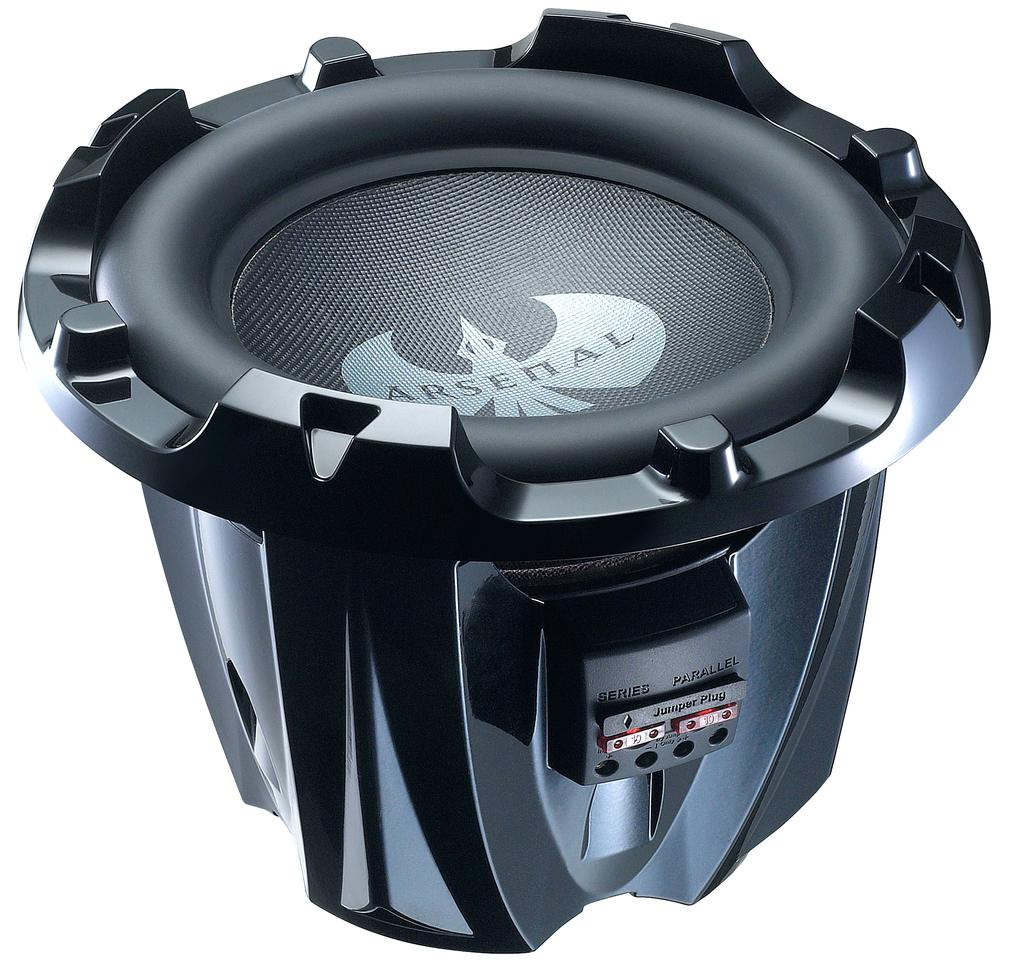What is the main object in the image? There is a subwoofer in the image. What color is the background of the image? The background of the image is white. Is there a partner holding an umbrella in the image? There is no partner or umbrella present in the image; it only features a subwoofer against a white background. 